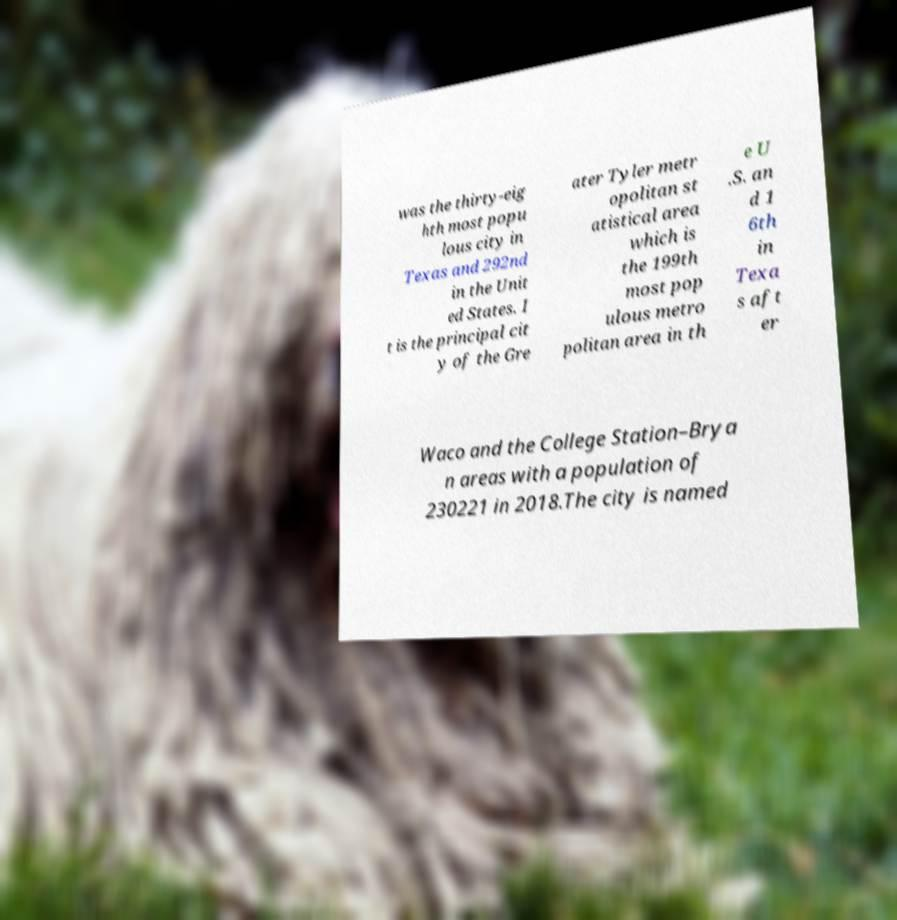Could you extract and type out the text from this image? was the thirty-eig hth most popu lous city in Texas and 292nd in the Unit ed States. I t is the principal cit y of the Gre ater Tyler metr opolitan st atistical area which is the 199th most pop ulous metro politan area in th e U .S. an d 1 6th in Texa s aft er Waco and the College Station–Brya n areas with a population of 230221 in 2018.The city is named 